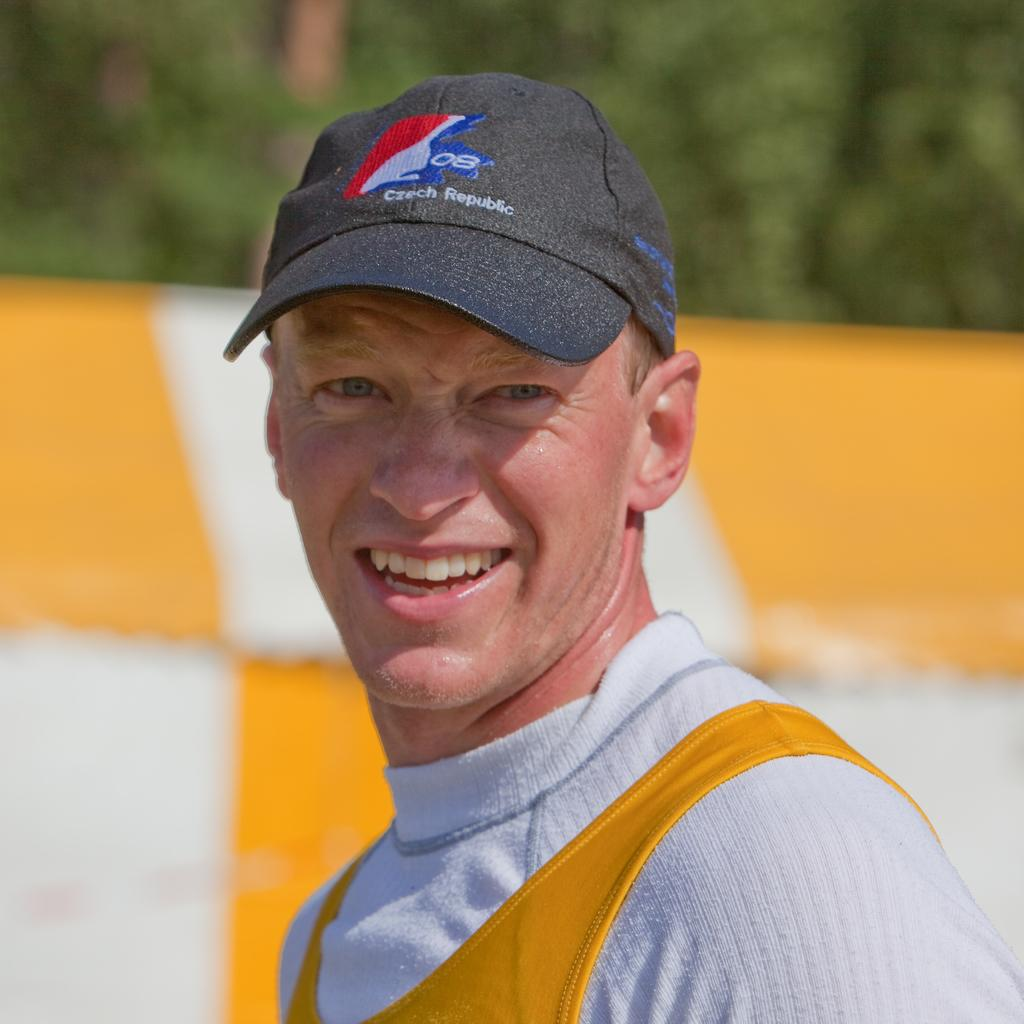<image>
Write a terse but informative summary of the picture. a man that is wearing a Czech Republic hat on their head 